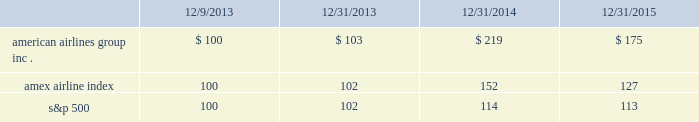Table of contents capital deployment program will be subject to market and economic conditions , applicable legal requirements and other relevant factors .
Our capital deployment program does not obligate us to continue a dividend for any fixed period , and payment of dividends may be suspended at any time at our discretion .
Stock performance graph the following stock performance graph and related information shall not be deemed 201csoliciting material 201d or 201cfiled 201d with the securities and exchange commission , nor shall such information be incorporated by reference into any future filings under the securities act of 1933 or the exchange act , each as amended , except to the extent that we specifically incorporate it by reference into such filing .
The following stock performance graph compares our cumulative total stockholder return on an annual basis on our common stock with the cumulative total return on the standard and poor 2019s 500 stock index and the amex airline index from december 9 , 2013 ( the first trading day of aag common stock ) through december 31 , 2015 .
The comparison assumes $ 100 was invested on december 9 , 2013 in aag common stock and in each of the foregoing indices and assumes reinvestment of dividends .
The stock performance shown on the graph below represents historical stock performance and is not necessarily indicative of future stock price performance. .
Purchases of equity securities by the issuer and affiliated purchasers since july 2014 , our board of directors has approved several share repurchase programs aggregating $ 7.0 billion of authority of which , as of december 31 , 2015 , $ 2.4 billion remained unused under repurchase programs .
What was the rate of growth or decrease from 2014 to 2015 on the american airlines group inc .? 
Rationale: the growth rate is the difference between the most recent and prior amount divided by the prior amount
Computations: ((175 - 219) / 219)
Answer: -0.20091. 